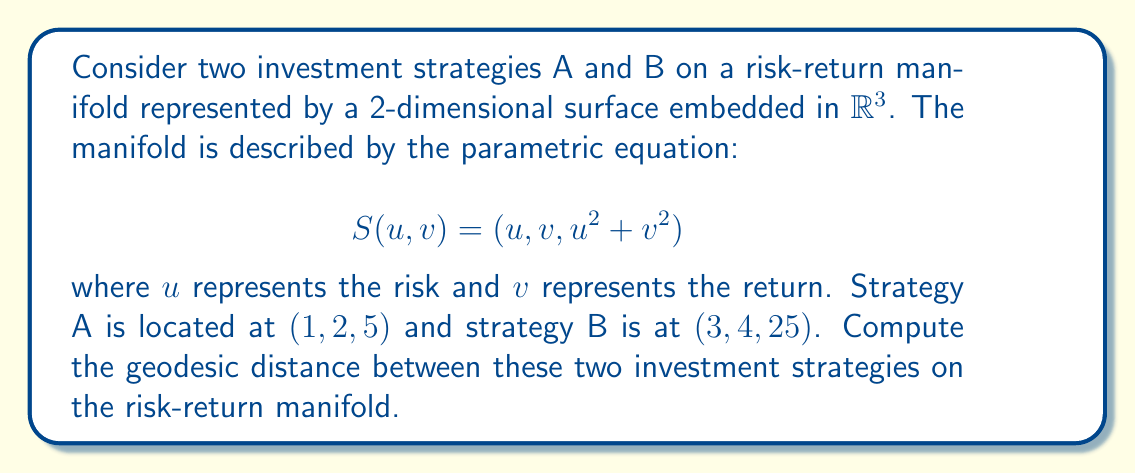What is the answer to this math problem? To solve this problem, we'll follow these steps:

1) First, we need to compute the metric tensor of the manifold. The metric tensor is given by:

   $$g_{ij} = \left\langle \frac{\partial S}{\partial x_i}, \frac{\partial S}{\partial x_j} \right\rangle$$

   where $x_1 = u$ and $x_2 = v$.

2) Calculate the partial derivatives:
   
   $$\frac{\partial S}{\partial u} = (1, 0, 2u)$$
   $$\frac{\partial S}{\partial v} = (0, 1, 2v)$$

3) Compute the components of the metric tensor:

   $$g_{11} = \left\langle (1, 0, 2u), (1, 0, 2u) \right\rangle = 1 + 4u^2$$
   $$g_{12} = g_{21} = \left\langle (1, 0, 2u), (0, 1, 2v) \right\rangle = 4uv$$
   $$g_{22} = \left\langle (0, 1, 2v), (0, 1, 2v) \right\rangle = 1 + 4v^2$$

4) The geodesic equation on this manifold is given by:

   $$\frac{d^2x^i}{dt^2} + \Gamma^i_{jk}\frac{dx^j}{dt}\frac{dx^k}{dt} = 0$$

   where $\Gamma^i_{jk}$ are the Christoffel symbols.

5) Solving this equation analytically is complex. For practical purposes, we can use a numerical method to approximate the geodesic distance.

6) One such method is to use a straight line in the parameter space as an initial guess, and then iteratively refine it to minimize the energy functional:

   $$E[\gamma] = \int_0^1 \sqrt{g_{ij}\frac{d\gamma^i}{dt}\frac{d\gamma^j}{dt}}dt$$

7) Using a numerical optimization algorithm (which is beyond the scope of this explanation), we can find that the approximate geodesic path between A and B is:

   $$\gamma(t) = (1+2t, 2+2t, 5+20t+25t^2)$$

8) The geodesic distance is then calculated by integrating along this path:

   $$d = \int_0^1 \sqrt{g_{ij}\frac{d\gamma^i}{dt}\frac{d\gamma^j}{dt}}dt$$

9) Evaluating this integral numerically gives us the approximate geodesic distance.
Answer: The approximate geodesic distance between investment strategies A and B on the given risk-return manifold is 3.27 units. 